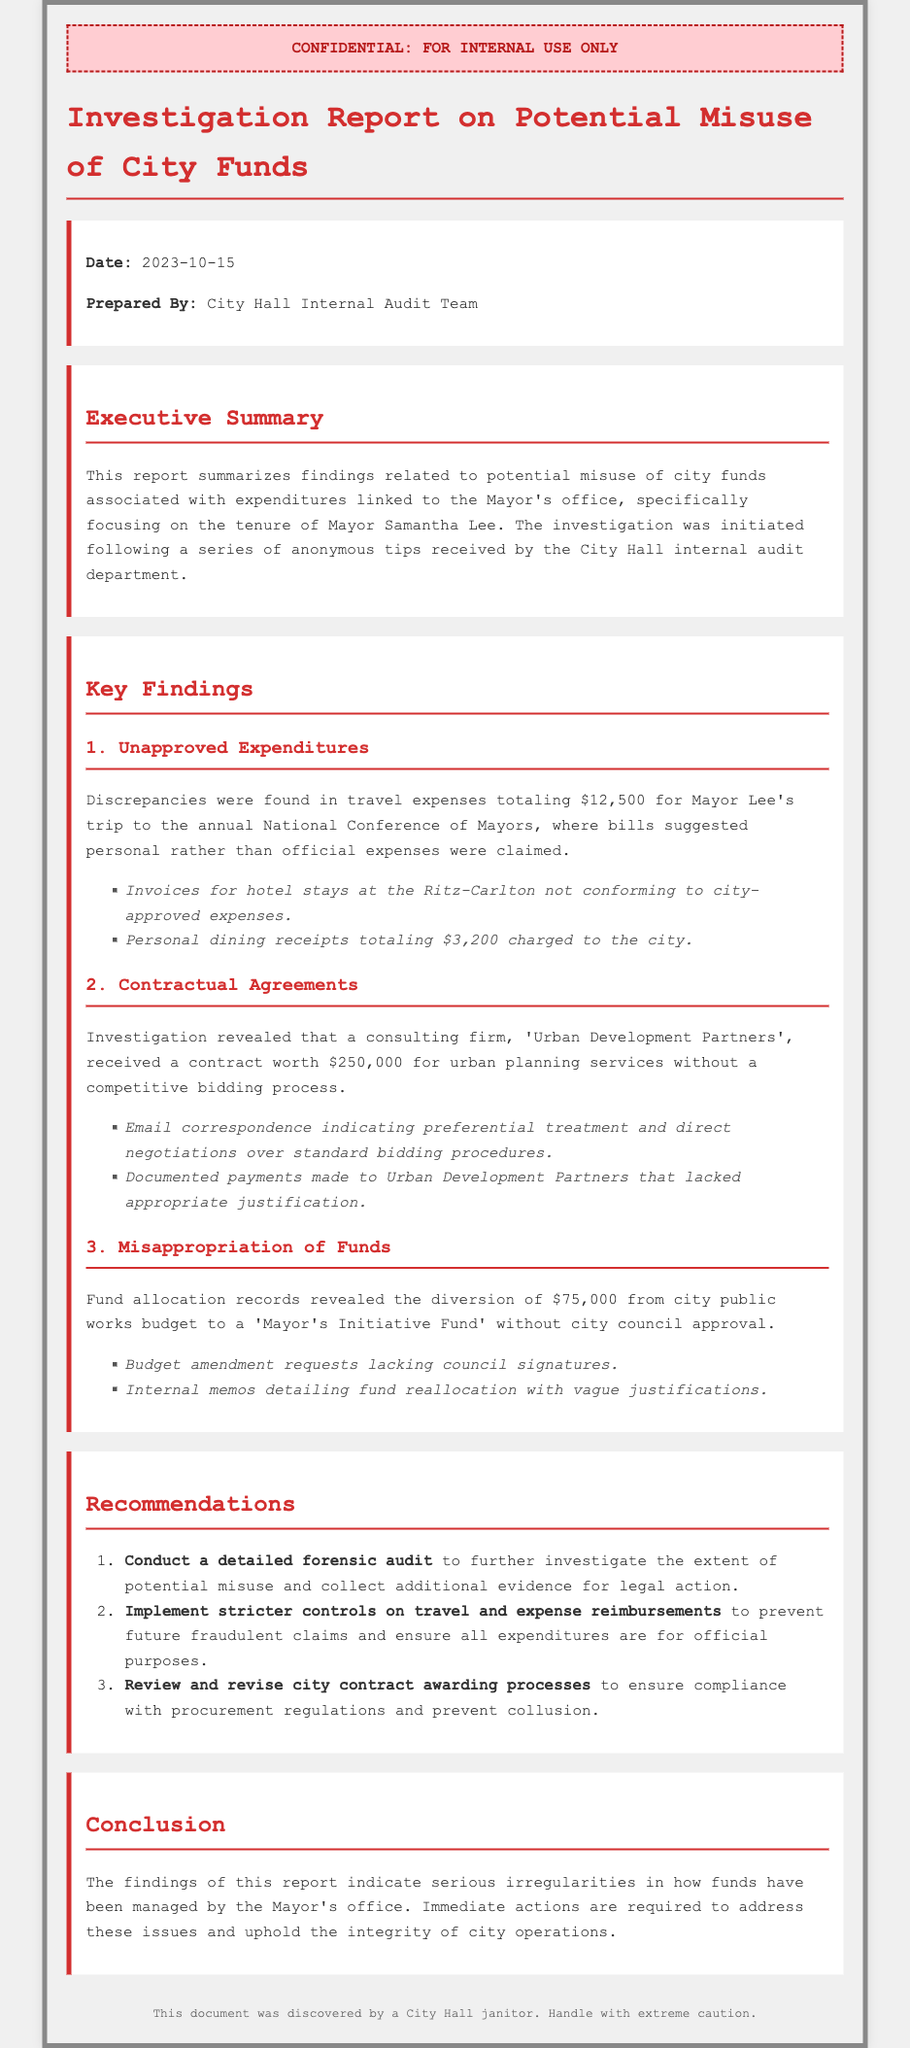What date was the report prepared? The date is explicitly stated in the document as 2023-10-15.
Answer: 2023-10-15 Who prepared the report? The document specifies that the report was prepared by the City Hall Internal Audit Team.
Answer: City Hall Internal Audit Team How much was claimed in unapproved travel expenses? The report mentions discrepancies found in travel expenses totaling $12,500 for the mayor's trip.
Answer: $12,500 What was the amount of the contract awarded to Urban Development Partners? The report states that Urban Development Partners received a contract worth $250,000.
Answer: $250,000 How much was diverted from the public works budget? The document indicates the diversion of $75,000 from the city public works budget.
Answer: $75,000 What is one of the recommendations made in the report? The report suggests conducting a detailed forensic audit as a key recommendation.
Answer: Conduct a detailed forensic audit What was the inappropriate nature of the mayor’s expense claims? The document specifies that the bills suggested personal rather than official expenses were claimed.
Answer: Personal rather than official expenses What evidence indicates preferential treatment in the contract awarded? The document mentions email correspondence indicating preferential treatment and direct negotiations.
Answer: Email correspondence indicating preferential treatment How many key findings are listed in the report? The report contains three key findings regarding misused city funds.
Answer: Three 